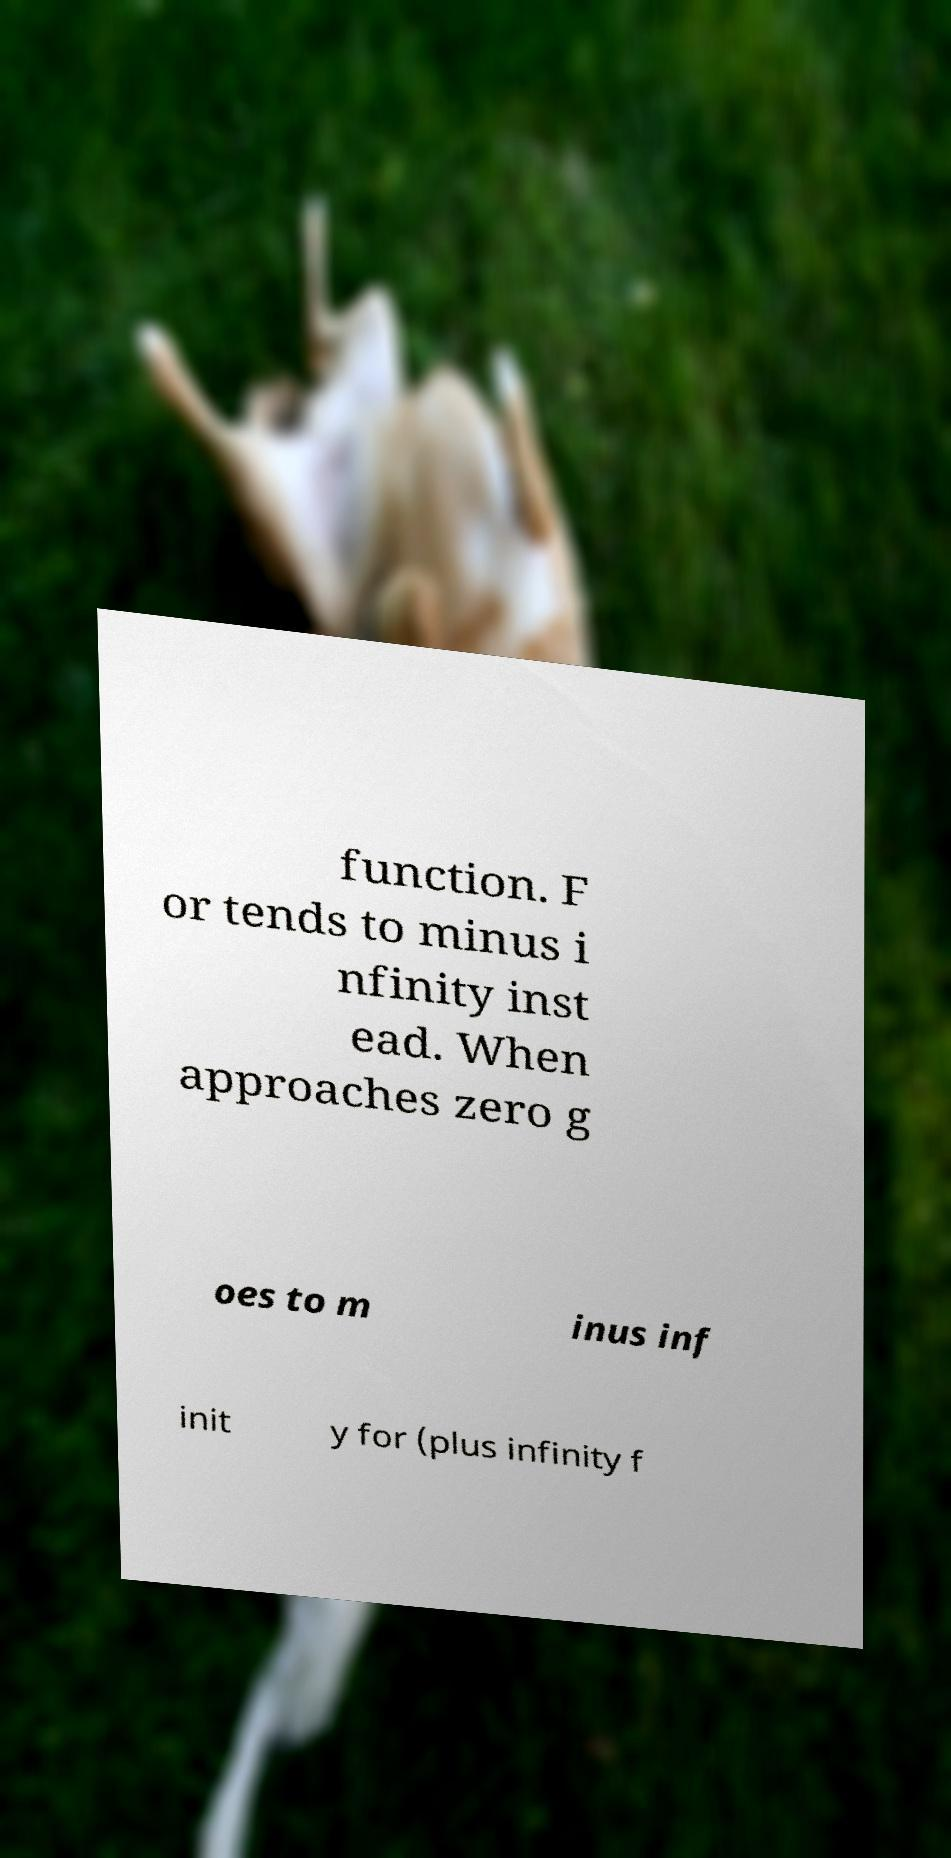Please read and relay the text visible in this image. What does it say? function. F or tends to minus i nfinity inst ead. When approaches zero g oes to m inus inf init y for (plus infinity f 